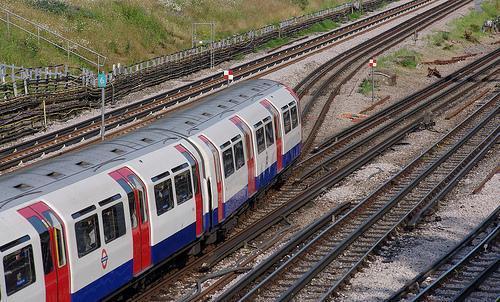How many trains are there?
Give a very brief answer. 1. 